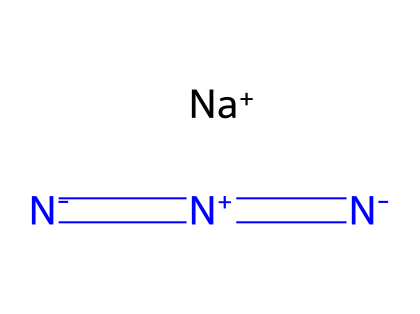How many different elements are present in sodium azide? The chemical structure indicates the presence of sodium (Na) and nitrogen (N) atoms. Counting the distinct elements gives us sodium and nitrogen as the two different elements in the formula.
Answer: two What is the oxidation state of nitrogen in sodium azide? In sodium azide, the nitrogen atoms are in different oxidation states. The terminal nitrogen (N-) has an oxidation state of -1, while the central nitrogen (N+) is +1, due to the bonding shown in its structure. Considering the azide ion, the average oxidation state is -1 as there are three nitrogen atoms with a net charge of -1.
Answer: -1 How many nitrogen atoms are present in sodium azide? The structure contains three nitrogen atoms, as indicated by the repeating nitrogen symbols in the formula.
Answer: three What type of bonding exists between the nitrogen atoms in sodium azide? In sodium azide, there is a combination of double and single bonds between nitrogen atoms, indicated by the notation in the SMILES representation ('=' for double bonds and single dash typically implied). This results in resonance stabilization across the nitrogen atoms.
Answer: double and single bonding What is the chemical nature of sodium azide in terms of solubility? Sodium azide is an ionic compound derived from sodium and the azide ion, which is generally soluble in water due to the ionic nature of the sodium salt in its structure. This makes it notably applicable in systems such as airbags.
Answer: soluble in water 